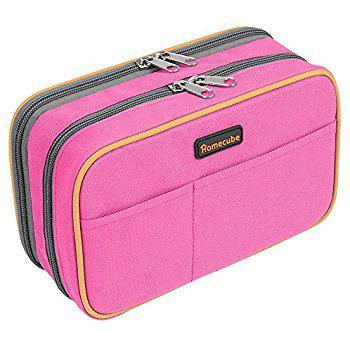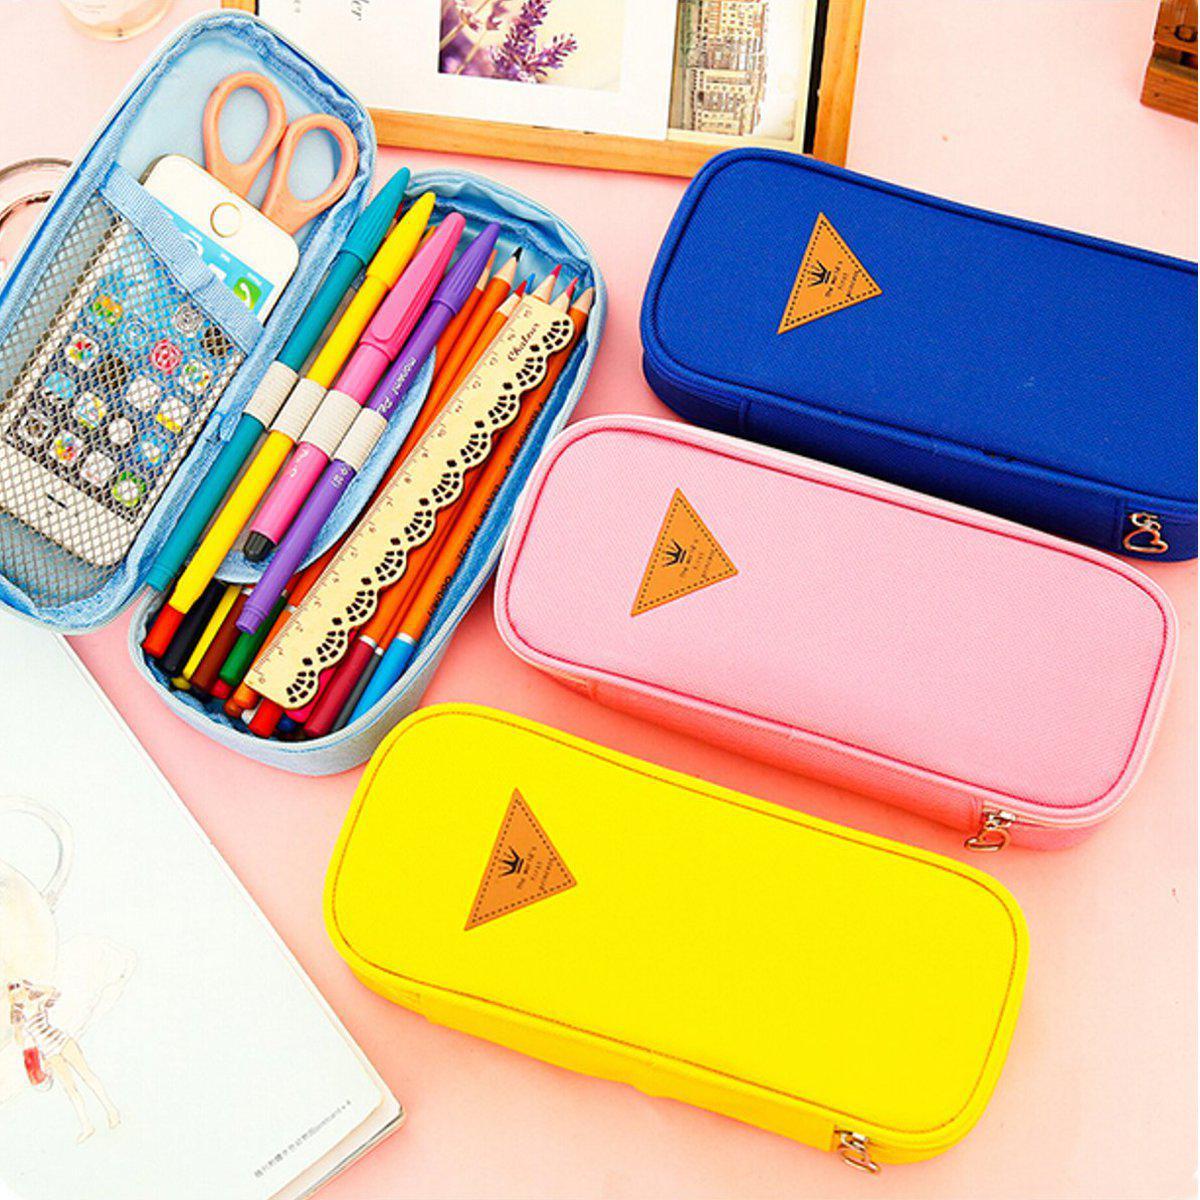The first image is the image on the left, the second image is the image on the right. Analyze the images presented: Is the assertion "At least one of the images shows multiple colored pencils that are secured inside of a case." valid? Answer yes or no. Yes. The first image is the image on the left, the second image is the image on the right. For the images shown, is this caption "There is an image of a single closed case and an image showing both the closed and open case." true? Answer yes or no. Yes. 